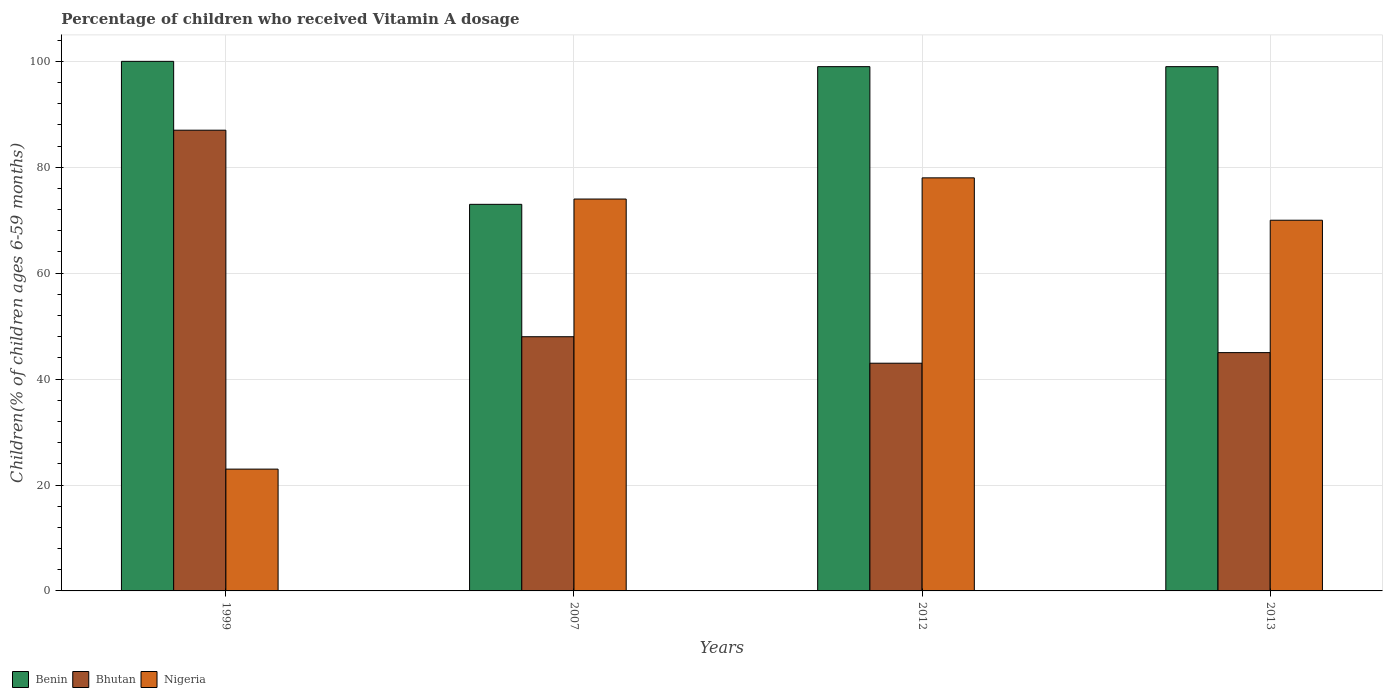Are the number of bars per tick equal to the number of legend labels?
Offer a terse response. Yes. Are the number of bars on each tick of the X-axis equal?
Keep it short and to the point. Yes. What is the label of the 1st group of bars from the left?
Ensure brevity in your answer.  1999. What is the percentage of children who received Vitamin A dosage in Benin in 2013?
Keep it short and to the point. 99. Across all years, what is the maximum percentage of children who received Vitamin A dosage in Bhutan?
Ensure brevity in your answer.  87. In which year was the percentage of children who received Vitamin A dosage in Benin maximum?
Your answer should be compact. 1999. What is the total percentage of children who received Vitamin A dosage in Nigeria in the graph?
Your answer should be compact. 245. What is the average percentage of children who received Vitamin A dosage in Bhutan per year?
Ensure brevity in your answer.  55.75. What is the ratio of the percentage of children who received Vitamin A dosage in Nigeria in 2012 to that in 2013?
Offer a very short reply. 1.11. Is the percentage of children who received Vitamin A dosage in Benin in 1999 less than that in 2012?
Make the answer very short. No. Is the difference between the percentage of children who received Vitamin A dosage in Benin in 2012 and 2013 greater than the difference between the percentage of children who received Vitamin A dosage in Nigeria in 2012 and 2013?
Your response must be concise. No. Is the sum of the percentage of children who received Vitamin A dosage in Benin in 1999 and 2007 greater than the maximum percentage of children who received Vitamin A dosage in Nigeria across all years?
Your response must be concise. Yes. What does the 2nd bar from the left in 2007 represents?
Offer a terse response. Bhutan. What does the 1st bar from the right in 2012 represents?
Provide a short and direct response. Nigeria. Are all the bars in the graph horizontal?
Offer a terse response. No. Are the values on the major ticks of Y-axis written in scientific E-notation?
Your response must be concise. No. Does the graph contain any zero values?
Your response must be concise. No. Where does the legend appear in the graph?
Your answer should be compact. Bottom left. How many legend labels are there?
Your answer should be very brief. 3. How are the legend labels stacked?
Your answer should be very brief. Horizontal. What is the title of the graph?
Provide a short and direct response. Percentage of children who received Vitamin A dosage. Does "Singapore" appear as one of the legend labels in the graph?
Offer a terse response. No. What is the label or title of the X-axis?
Make the answer very short. Years. What is the label or title of the Y-axis?
Offer a very short reply. Children(% of children ages 6-59 months). What is the Children(% of children ages 6-59 months) of Benin in 1999?
Keep it short and to the point. 100. What is the Children(% of children ages 6-59 months) of Nigeria in 1999?
Offer a very short reply. 23. What is the Children(% of children ages 6-59 months) of Benin in 2007?
Your response must be concise. 73. What is the Children(% of children ages 6-59 months) of Bhutan in 2007?
Give a very brief answer. 48. What is the Children(% of children ages 6-59 months) of Benin in 2012?
Your answer should be very brief. 99. What is the Children(% of children ages 6-59 months) of Nigeria in 2012?
Provide a short and direct response. 78. What is the Children(% of children ages 6-59 months) in Benin in 2013?
Provide a short and direct response. 99. What is the Children(% of children ages 6-59 months) in Nigeria in 2013?
Ensure brevity in your answer.  70. Across all years, what is the maximum Children(% of children ages 6-59 months) of Nigeria?
Your answer should be compact. 78. What is the total Children(% of children ages 6-59 months) in Benin in the graph?
Offer a very short reply. 371. What is the total Children(% of children ages 6-59 months) in Bhutan in the graph?
Your answer should be very brief. 223. What is the total Children(% of children ages 6-59 months) of Nigeria in the graph?
Offer a very short reply. 245. What is the difference between the Children(% of children ages 6-59 months) in Benin in 1999 and that in 2007?
Offer a very short reply. 27. What is the difference between the Children(% of children ages 6-59 months) of Nigeria in 1999 and that in 2007?
Keep it short and to the point. -51. What is the difference between the Children(% of children ages 6-59 months) in Benin in 1999 and that in 2012?
Your response must be concise. 1. What is the difference between the Children(% of children ages 6-59 months) of Bhutan in 1999 and that in 2012?
Provide a succinct answer. 44. What is the difference between the Children(% of children ages 6-59 months) in Nigeria in 1999 and that in 2012?
Provide a short and direct response. -55. What is the difference between the Children(% of children ages 6-59 months) in Bhutan in 1999 and that in 2013?
Offer a terse response. 42. What is the difference between the Children(% of children ages 6-59 months) in Nigeria in 1999 and that in 2013?
Your answer should be compact. -47. What is the difference between the Children(% of children ages 6-59 months) in Benin in 2007 and that in 2012?
Offer a very short reply. -26. What is the difference between the Children(% of children ages 6-59 months) of Nigeria in 2007 and that in 2012?
Your answer should be compact. -4. What is the difference between the Children(% of children ages 6-59 months) of Nigeria in 2012 and that in 2013?
Make the answer very short. 8. What is the difference between the Children(% of children ages 6-59 months) in Benin in 1999 and the Children(% of children ages 6-59 months) in Nigeria in 2007?
Give a very brief answer. 26. What is the difference between the Children(% of children ages 6-59 months) of Bhutan in 1999 and the Children(% of children ages 6-59 months) of Nigeria in 2007?
Provide a succinct answer. 13. What is the difference between the Children(% of children ages 6-59 months) in Benin in 1999 and the Children(% of children ages 6-59 months) in Bhutan in 2012?
Provide a succinct answer. 57. What is the difference between the Children(% of children ages 6-59 months) in Benin in 1999 and the Children(% of children ages 6-59 months) in Nigeria in 2012?
Provide a short and direct response. 22. What is the difference between the Children(% of children ages 6-59 months) in Bhutan in 1999 and the Children(% of children ages 6-59 months) in Nigeria in 2012?
Ensure brevity in your answer.  9. What is the difference between the Children(% of children ages 6-59 months) in Benin in 1999 and the Children(% of children ages 6-59 months) in Bhutan in 2013?
Provide a succinct answer. 55. What is the difference between the Children(% of children ages 6-59 months) of Bhutan in 1999 and the Children(% of children ages 6-59 months) of Nigeria in 2013?
Provide a short and direct response. 17. What is the difference between the Children(% of children ages 6-59 months) in Benin in 2007 and the Children(% of children ages 6-59 months) in Bhutan in 2012?
Your response must be concise. 30. What is the difference between the Children(% of children ages 6-59 months) of Benin in 2007 and the Children(% of children ages 6-59 months) of Nigeria in 2012?
Keep it short and to the point. -5. What is the difference between the Children(% of children ages 6-59 months) in Bhutan in 2007 and the Children(% of children ages 6-59 months) in Nigeria in 2012?
Your response must be concise. -30. What is the difference between the Children(% of children ages 6-59 months) of Benin in 2007 and the Children(% of children ages 6-59 months) of Bhutan in 2013?
Keep it short and to the point. 28. What is the difference between the Children(% of children ages 6-59 months) of Bhutan in 2007 and the Children(% of children ages 6-59 months) of Nigeria in 2013?
Make the answer very short. -22. What is the difference between the Children(% of children ages 6-59 months) of Benin in 2012 and the Children(% of children ages 6-59 months) of Nigeria in 2013?
Your answer should be very brief. 29. What is the difference between the Children(% of children ages 6-59 months) in Bhutan in 2012 and the Children(% of children ages 6-59 months) in Nigeria in 2013?
Your response must be concise. -27. What is the average Children(% of children ages 6-59 months) in Benin per year?
Keep it short and to the point. 92.75. What is the average Children(% of children ages 6-59 months) in Bhutan per year?
Your answer should be very brief. 55.75. What is the average Children(% of children ages 6-59 months) in Nigeria per year?
Your answer should be compact. 61.25. In the year 1999, what is the difference between the Children(% of children ages 6-59 months) of Benin and Children(% of children ages 6-59 months) of Bhutan?
Your answer should be very brief. 13. In the year 1999, what is the difference between the Children(% of children ages 6-59 months) in Bhutan and Children(% of children ages 6-59 months) in Nigeria?
Give a very brief answer. 64. In the year 2007, what is the difference between the Children(% of children ages 6-59 months) in Benin and Children(% of children ages 6-59 months) in Nigeria?
Provide a short and direct response. -1. In the year 2007, what is the difference between the Children(% of children ages 6-59 months) in Bhutan and Children(% of children ages 6-59 months) in Nigeria?
Provide a succinct answer. -26. In the year 2012, what is the difference between the Children(% of children ages 6-59 months) in Bhutan and Children(% of children ages 6-59 months) in Nigeria?
Offer a very short reply. -35. In the year 2013, what is the difference between the Children(% of children ages 6-59 months) of Benin and Children(% of children ages 6-59 months) of Nigeria?
Your response must be concise. 29. In the year 2013, what is the difference between the Children(% of children ages 6-59 months) of Bhutan and Children(% of children ages 6-59 months) of Nigeria?
Ensure brevity in your answer.  -25. What is the ratio of the Children(% of children ages 6-59 months) in Benin in 1999 to that in 2007?
Offer a very short reply. 1.37. What is the ratio of the Children(% of children ages 6-59 months) of Bhutan in 1999 to that in 2007?
Give a very brief answer. 1.81. What is the ratio of the Children(% of children ages 6-59 months) in Nigeria in 1999 to that in 2007?
Keep it short and to the point. 0.31. What is the ratio of the Children(% of children ages 6-59 months) in Bhutan in 1999 to that in 2012?
Offer a terse response. 2.02. What is the ratio of the Children(% of children ages 6-59 months) in Nigeria in 1999 to that in 2012?
Keep it short and to the point. 0.29. What is the ratio of the Children(% of children ages 6-59 months) in Bhutan in 1999 to that in 2013?
Give a very brief answer. 1.93. What is the ratio of the Children(% of children ages 6-59 months) of Nigeria in 1999 to that in 2013?
Offer a terse response. 0.33. What is the ratio of the Children(% of children ages 6-59 months) of Benin in 2007 to that in 2012?
Offer a very short reply. 0.74. What is the ratio of the Children(% of children ages 6-59 months) in Bhutan in 2007 to that in 2012?
Your response must be concise. 1.12. What is the ratio of the Children(% of children ages 6-59 months) in Nigeria in 2007 to that in 2012?
Make the answer very short. 0.95. What is the ratio of the Children(% of children ages 6-59 months) of Benin in 2007 to that in 2013?
Your answer should be very brief. 0.74. What is the ratio of the Children(% of children ages 6-59 months) of Bhutan in 2007 to that in 2013?
Make the answer very short. 1.07. What is the ratio of the Children(% of children ages 6-59 months) of Nigeria in 2007 to that in 2013?
Keep it short and to the point. 1.06. What is the ratio of the Children(% of children ages 6-59 months) of Benin in 2012 to that in 2013?
Provide a succinct answer. 1. What is the ratio of the Children(% of children ages 6-59 months) in Bhutan in 2012 to that in 2013?
Make the answer very short. 0.96. What is the ratio of the Children(% of children ages 6-59 months) of Nigeria in 2012 to that in 2013?
Ensure brevity in your answer.  1.11. What is the difference between the highest and the second highest Children(% of children ages 6-59 months) of Bhutan?
Your answer should be very brief. 39. What is the difference between the highest and the second highest Children(% of children ages 6-59 months) in Nigeria?
Your response must be concise. 4. What is the difference between the highest and the lowest Children(% of children ages 6-59 months) of Benin?
Your answer should be compact. 27. What is the difference between the highest and the lowest Children(% of children ages 6-59 months) of Bhutan?
Your answer should be very brief. 44. 